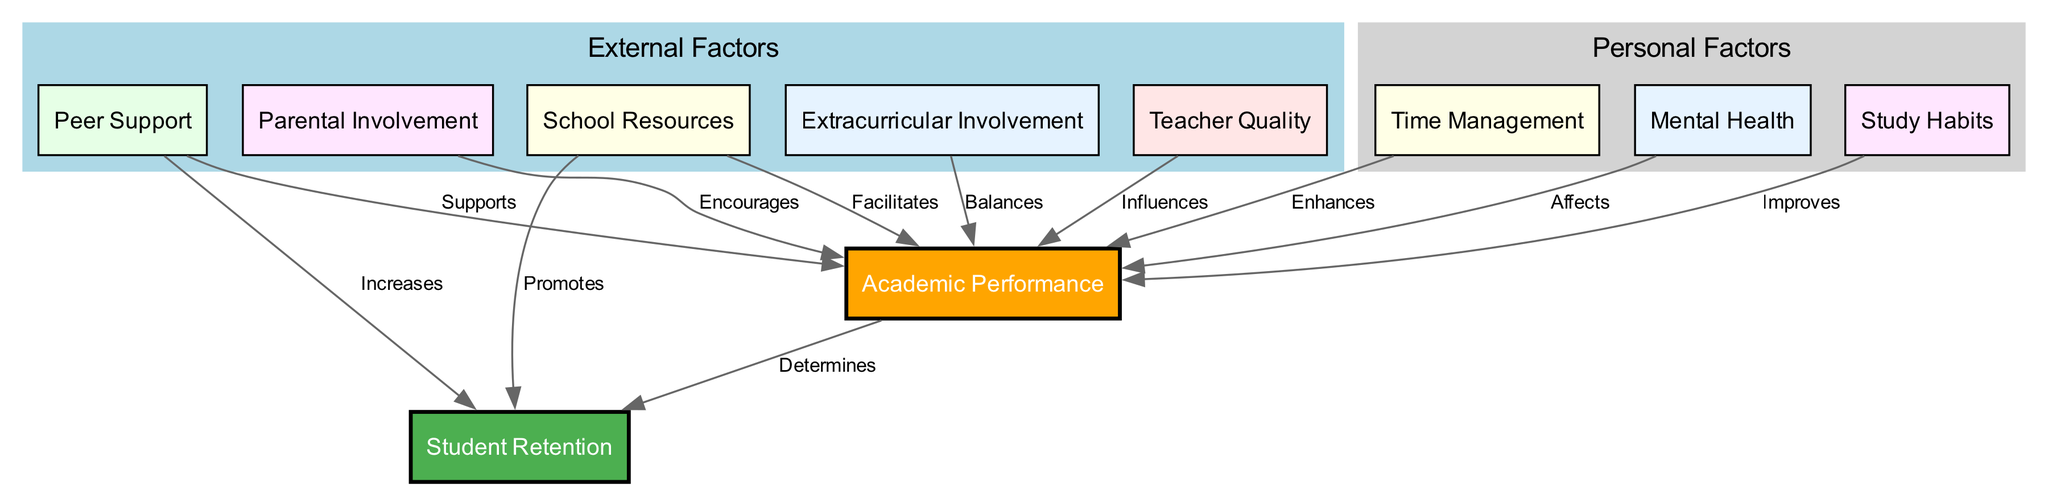What is the main output of the diagram? The main output of the diagram is "Student Retention," which is represented by the second node in the diagram, showing the ultimate goal of the system dynamics model.
Answer: Student Retention How many nodes are present in the diagram? The diagram contains a total of ten nodes, identifiable by counting each unique factor affecting student academic performance and retention.
Answer: 10 Which node directly influences "Academic Performance" alongside "Study Habits"? "Time Management" directly influences "Academic Performance," as indicated by an edge emerging from the "Time Management" node towards the "Academic Performance" node, making it an important factor similar to "Study Habits."
Answer: Time Management What factor is indicated to "Promote" student retention? "School Resources" is indicated to "Promote" student retention, which is identified by the label on the edge connecting the "School Resources" node to the "Student Retention" node.
Answer: School Resources Which personal factors influence "Academic Performance"? The personal factors influencing "Academic Performance" include "Study Habits," "Time Management," and "Mental Health," which are all nodes connected to the "Academic Performance" node with respective edges that depict their positive influence.
Answer: Study Habits, Time Management, Mental Health How does "Parental Involvement" relate to "Academic Performance"? "Parental Involvement" is shown to encourage "Academic Performance," as indicated by the edge connecting the "Parental Involvement" node to the "Academic Performance" node with the label "Encourages."
Answer: Encourages What role does "Peer Support" play according to the diagram? "Peer Support" plays a dual role by both supporting "Academic Performance" and increasing "Student Retention," as seen from two separate edges emanating from the "Peer Support" node, indicating its significant role in both aspects.
Answer: Supports, Increases How many edges connect to "Academic Performance"? There are seven edges connecting to "Academic Performance," indicating the multiple factors listed in nodes that directly influence academic performance.
Answer: 7 Which external factor affects student retention and how? "School Resources" affects student retention by promoting it, as indicated by the edge connecting from the "School Resources" node to the "Student Retention" node, demonstrating its positive contribution.
Answer: Promotes What is the relationship between "Teacher Quality" and "Academic Performance"? "Teacher Quality" influences "Academic Performance," as described by the edge leading from the "Teacher Quality" node to the "Academic Performance" node with the label "Influences."
Answer: Influences 